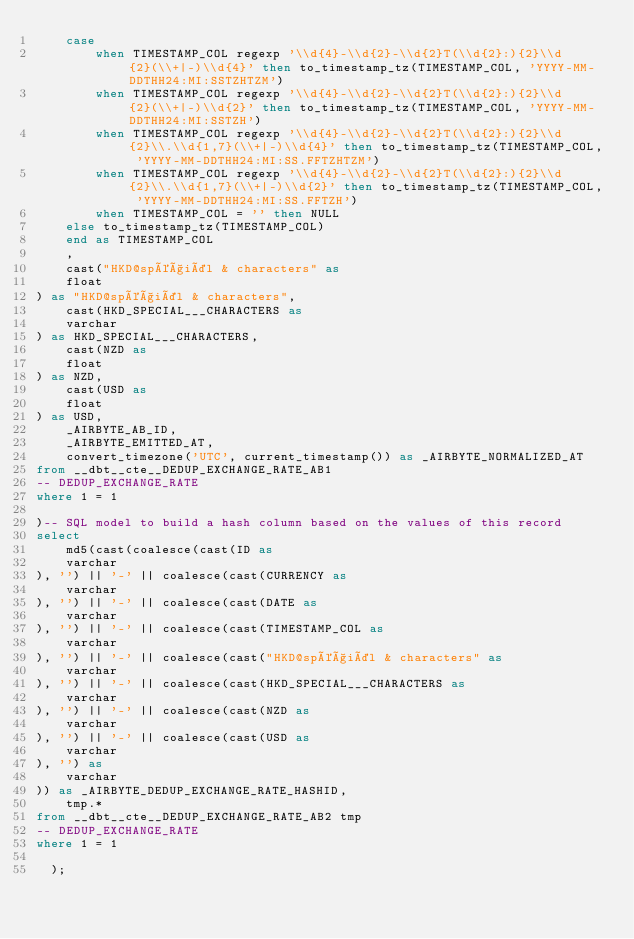<code> <loc_0><loc_0><loc_500><loc_500><_SQL_>    case
        when TIMESTAMP_COL regexp '\\d{4}-\\d{2}-\\d{2}T(\\d{2}:){2}\\d{2}(\\+|-)\\d{4}' then to_timestamp_tz(TIMESTAMP_COL, 'YYYY-MM-DDTHH24:MI:SSTZHTZM')
        when TIMESTAMP_COL regexp '\\d{4}-\\d{2}-\\d{2}T(\\d{2}:){2}\\d{2}(\\+|-)\\d{2}' then to_timestamp_tz(TIMESTAMP_COL, 'YYYY-MM-DDTHH24:MI:SSTZH')
        when TIMESTAMP_COL regexp '\\d{4}-\\d{2}-\\d{2}T(\\d{2}:){2}\\d{2}\\.\\d{1,7}(\\+|-)\\d{4}' then to_timestamp_tz(TIMESTAMP_COL, 'YYYY-MM-DDTHH24:MI:SS.FFTZHTZM')
        when TIMESTAMP_COL regexp '\\d{4}-\\d{2}-\\d{2}T(\\d{2}:){2}\\d{2}\\.\\d{1,7}(\\+|-)\\d{2}' then to_timestamp_tz(TIMESTAMP_COL, 'YYYY-MM-DDTHH24:MI:SS.FFTZH')
        when TIMESTAMP_COL = '' then NULL
    else to_timestamp_tz(TIMESTAMP_COL)
    end as TIMESTAMP_COL
    ,
    cast("HKD@spéçiäl & characters" as 
    float
) as "HKD@spéçiäl & characters",
    cast(HKD_SPECIAL___CHARACTERS as 
    varchar
) as HKD_SPECIAL___CHARACTERS,
    cast(NZD as 
    float
) as NZD,
    cast(USD as 
    float
) as USD,
    _AIRBYTE_AB_ID,
    _AIRBYTE_EMITTED_AT,
    convert_timezone('UTC', current_timestamp()) as _AIRBYTE_NORMALIZED_AT
from __dbt__cte__DEDUP_EXCHANGE_RATE_AB1
-- DEDUP_EXCHANGE_RATE
where 1 = 1

)-- SQL model to build a hash column based on the values of this record
select
    md5(cast(coalesce(cast(ID as 
    varchar
), '') || '-' || coalesce(cast(CURRENCY as 
    varchar
), '') || '-' || coalesce(cast(DATE as 
    varchar
), '') || '-' || coalesce(cast(TIMESTAMP_COL as 
    varchar
), '') || '-' || coalesce(cast("HKD@spéçiäl & characters" as 
    varchar
), '') || '-' || coalesce(cast(HKD_SPECIAL___CHARACTERS as 
    varchar
), '') || '-' || coalesce(cast(NZD as 
    varchar
), '') || '-' || coalesce(cast(USD as 
    varchar
), '') as 
    varchar
)) as _AIRBYTE_DEDUP_EXCHANGE_RATE_HASHID,
    tmp.*
from __dbt__cte__DEDUP_EXCHANGE_RATE_AB2 tmp
-- DEDUP_EXCHANGE_RATE
where 1 = 1

  );
</code> 